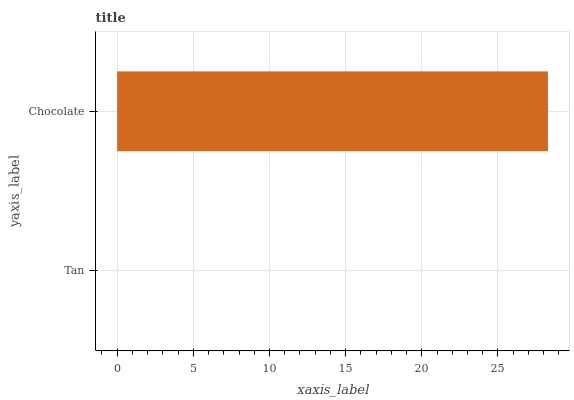Is Tan the minimum?
Answer yes or no. Yes. Is Chocolate the maximum?
Answer yes or no. Yes. Is Chocolate the minimum?
Answer yes or no. No. Is Chocolate greater than Tan?
Answer yes or no. Yes. Is Tan less than Chocolate?
Answer yes or no. Yes. Is Tan greater than Chocolate?
Answer yes or no. No. Is Chocolate less than Tan?
Answer yes or no. No. Is Chocolate the high median?
Answer yes or no. Yes. Is Tan the low median?
Answer yes or no. Yes. Is Tan the high median?
Answer yes or no. No. Is Chocolate the low median?
Answer yes or no. No. 